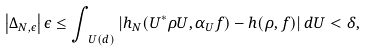<formula> <loc_0><loc_0><loc_500><loc_500>\left | \Delta _ { N , \epsilon } \right | \epsilon \leq \int _ { \ U ( d ) } \left | h _ { N } ( U ^ { * } \rho U , \alpha _ { U } f ) - h ( \rho , f ) \right | d U < \delta ,</formula> 